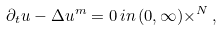Convert formula to latex. <formula><loc_0><loc_0><loc_500><loc_500>\partial _ { t } u - \Delta u ^ { m } = 0 \, i n \, ( 0 , \infty ) \times \real ^ { N } \, ,</formula> 